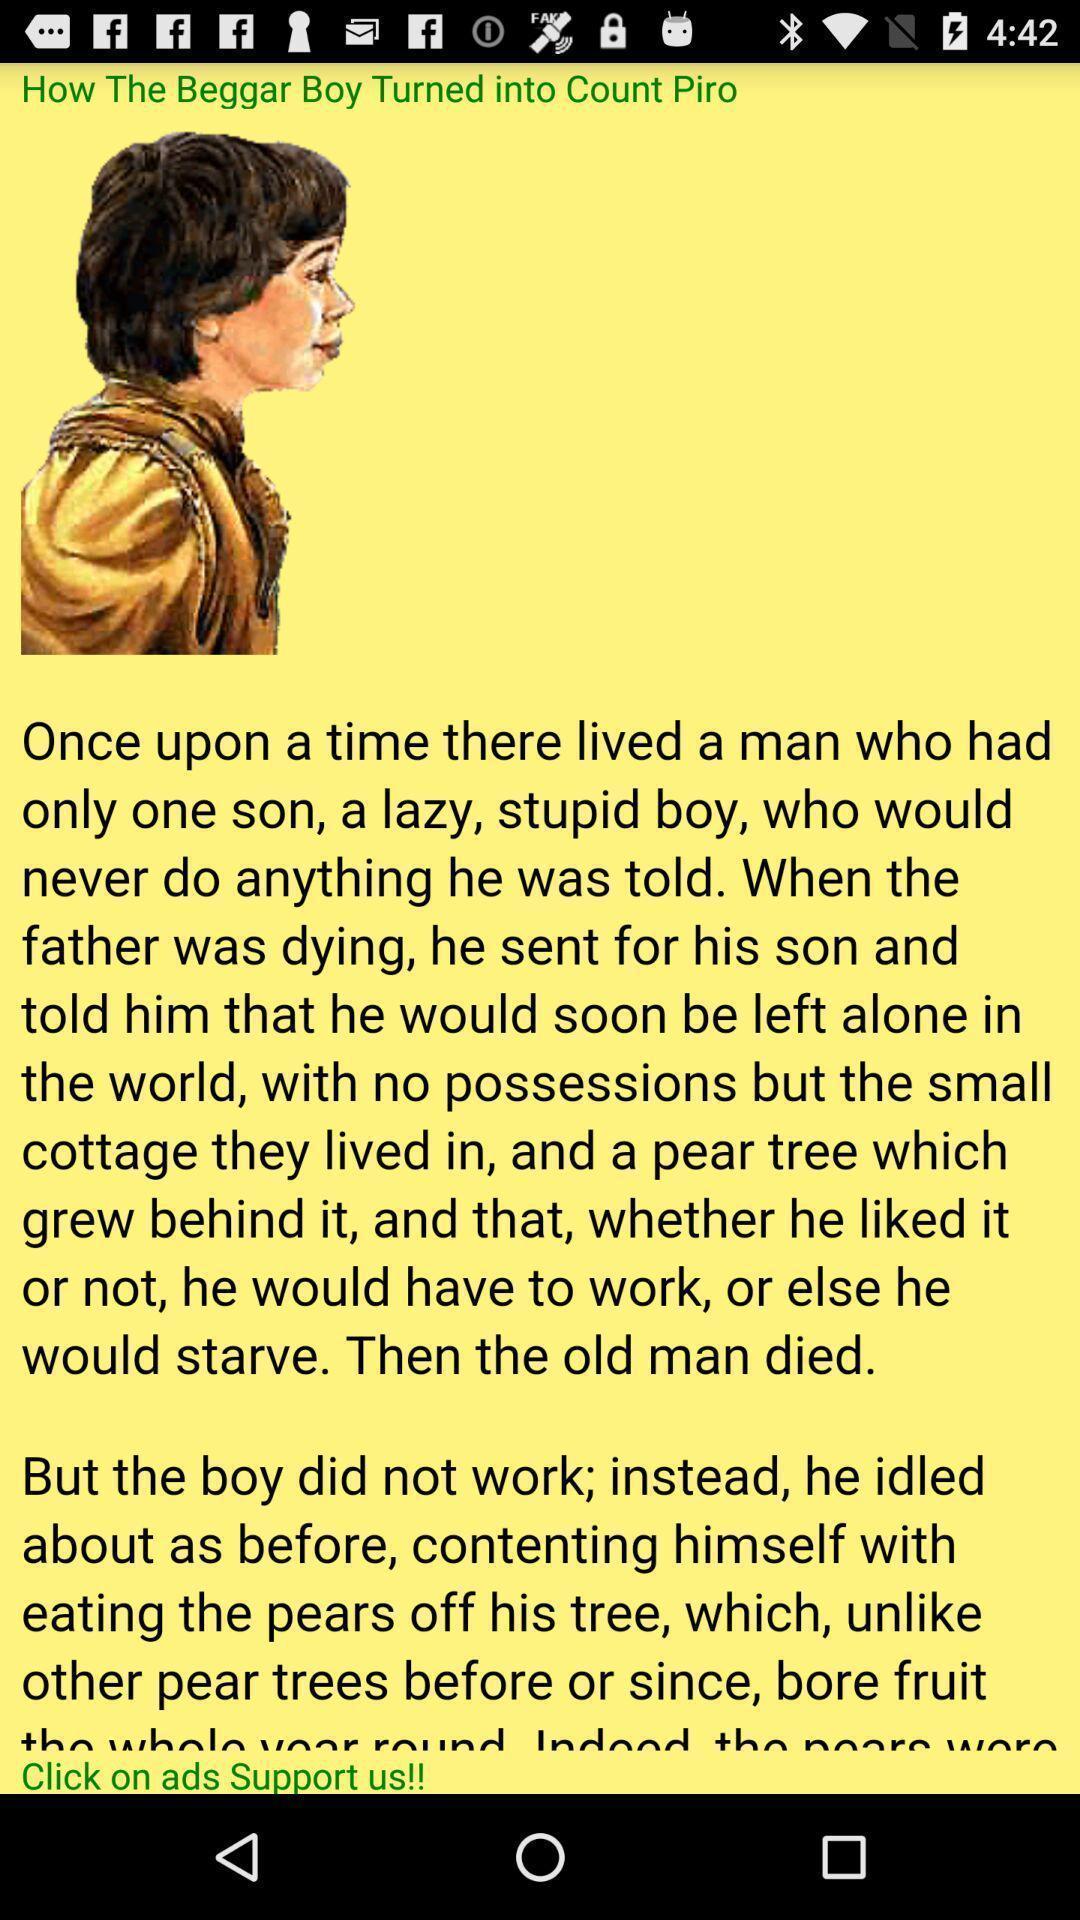Explain what's happening in this screen capture. Page displaying an animated image and text. 